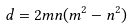<formula> <loc_0><loc_0><loc_500><loc_500>d = 2 m n ( m ^ { 2 } - n ^ { 2 } )</formula> 